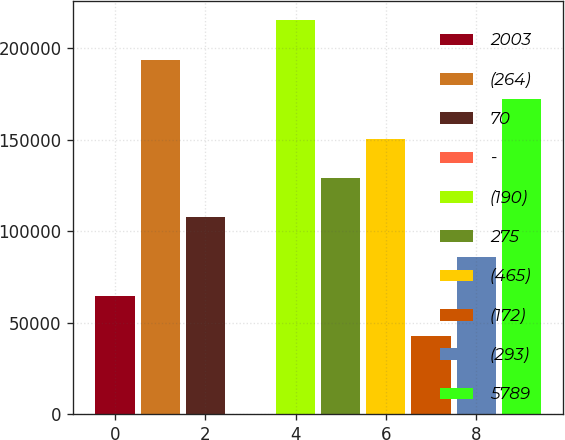<chart> <loc_0><loc_0><loc_500><loc_500><bar_chart><fcel>2003<fcel>(264)<fcel>70<fcel>-<fcel>(190)<fcel>275<fcel>(465)<fcel>(172)<fcel>(293)<fcel>5789<nl><fcel>64566.2<fcel>193695<fcel>107609<fcel>2<fcel>215216<fcel>129130<fcel>150652<fcel>43044.8<fcel>86087.6<fcel>172173<nl></chart> 